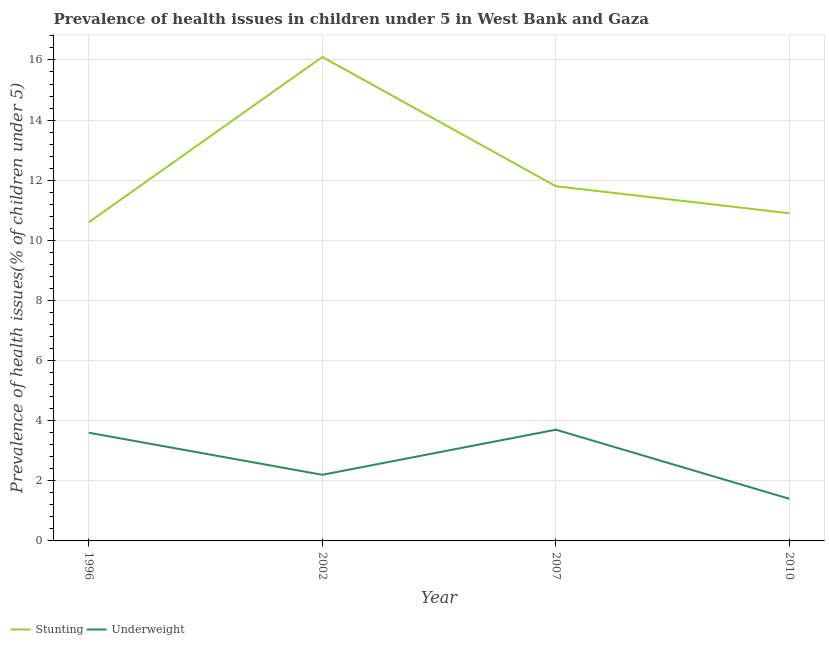Does the line corresponding to percentage of underweight children intersect with the line corresponding to percentage of stunted children?
Your answer should be very brief. No. What is the percentage of stunted children in 2007?
Offer a terse response. 11.8. Across all years, what is the maximum percentage of underweight children?
Ensure brevity in your answer.  3.7. Across all years, what is the minimum percentage of underweight children?
Ensure brevity in your answer.  1.4. In which year was the percentage of underweight children maximum?
Make the answer very short. 2007. What is the total percentage of underweight children in the graph?
Your answer should be very brief. 10.9. What is the difference between the percentage of underweight children in 1996 and that in 2002?
Offer a very short reply. 1.4. What is the difference between the percentage of stunted children in 2007 and the percentage of underweight children in 2002?
Provide a short and direct response. 9.6. What is the average percentage of stunted children per year?
Provide a succinct answer. 12.35. In the year 2007, what is the difference between the percentage of stunted children and percentage of underweight children?
Ensure brevity in your answer.  8.1. In how many years, is the percentage of stunted children greater than 11.2 %?
Give a very brief answer. 2. What is the ratio of the percentage of stunted children in 1996 to that in 2010?
Make the answer very short. 0.97. Is the percentage of underweight children in 2007 less than that in 2010?
Your response must be concise. No. What is the difference between the highest and the second highest percentage of underweight children?
Give a very brief answer. 0.1. What is the difference between the highest and the lowest percentage of underweight children?
Keep it short and to the point. 2.3. In how many years, is the percentage of underweight children greater than the average percentage of underweight children taken over all years?
Keep it short and to the point. 2. Does the percentage of stunted children monotonically increase over the years?
Keep it short and to the point. No. Is the percentage of underweight children strictly less than the percentage of stunted children over the years?
Offer a very short reply. Yes. How many lines are there?
Make the answer very short. 2. What is the difference between two consecutive major ticks on the Y-axis?
Make the answer very short. 2. Does the graph contain grids?
Your response must be concise. Yes. How many legend labels are there?
Your response must be concise. 2. How are the legend labels stacked?
Provide a short and direct response. Horizontal. What is the title of the graph?
Keep it short and to the point. Prevalence of health issues in children under 5 in West Bank and Gaza. What is the label or title of the Y-axis?
Provide a short and direct response. Prevalence of health issues(% of children under 5). What is the Prevalence of health issues(% of children under 5) in Stunting in 1996?
Offer a very short reply. 10.6. What is the Prevalence of health issues(% of children under 5) in Underweight in 1996?
Keep it short and to the point. 3.6. What is the Prevalence of health issues(% of children under 5) of Stunting in 2002?
Make the answer very short. 16.1. What is the Prevalence of health issues(% of children under 5) in Underweight in 2002?
Provide a succinct answer. 2.2. What is the Prevalence of health issues(% of children under 5) of Stunting in 2007?
Offer a terse response. 11.8. What is the Prevalence of health issues(% of children under 5) in Underweight in 2007?
Provide a short and direct response. 3.7. What is the Prevalence of health issues(% of children under 5) of Stunting in 2010?
Your answer should be very brief. 10.9. What is the Prevalence of health issues(% of children under 5) of Underweight in 2010?
Ensure brevity in your answer.  1.4. Across all years, what is the maximum Prevalence of health issues(% of children under 5) of Stunting?
Offer a terse response. 16.1. Across all years, what is the maximum Prevalence of health issues(% of children under 5) of Underweight?
Keep it short and to the point. 3.7. Across all years, what is the minimum Prevalence of health issues(% of children under 5) in Stunting?
Your answer should be compact. 10.6. Across all years, what is the minimum Prevalence of health issues(% of children under 5) in Underweight?
Provide a short and direct response. 1.4. What is the total Prevalence of health issues(% of children under 5) in Stunting in the graph?
Your answer should be compact. 49.4. What is the difference between the Prevalence of health issues(% of children under 5) in Underweight in 1996 and that in 2002?
Your response must be concise. 1.4. What is the difference between the Prevalence of health issues(% of children under 5) in Underweight in 1996 and that in 2007?
Give a very brief answer. -0.1. What is the difference between the Prevalence of health issues(% of children under 5) in Underweight in 1996 and that in 2010?
Provide a succinct answer. 2.2. What is the difference between the Prevalence of health issues(% of children under 5) of Underweight in 2002 and that in 2007?
Your answer should be very brief. -1.5. What is the difference between the Prevalence of health issues(% of children under 5) in Underweight in 2002 and that in 2010?
Provide a short and direct response. 0.8. What is the difference between the Prevalence of health issues(% of children under 5) in Stunting in 2007 and that in 2010?
Provide a short and direct response. 0.9. What is the difference between the Prevalence of health issues(% of children under 5) of Stunting in 1996 and the Prevalence of health issues(% of children under 5) of Underweight in 2007?
Make the answer very short. 6.9. What is the difference between the Prevalence of health issues(% of children under 5) in Stunting in 1996 and the Prevalence of health issues(% of children under 5) in Underweight in 2010?
Ensure brevity in your answer.  9.2. What is the difference between the Prevalence of health issues(% of children under 5) of Stunting in 2002 and the Prevalence of health issues(% of children under 5) of Underweight in 2007?
Make the answer very short. 12.4. What is the average Prevalence of health issues(% of children under 5) of Stunting per year?
Provide a short and direct response. 12.35. What is the average Prevalence of health issues(% of children under 5) in Underweight per year?
Keep it short and to the point. 2.73. In the year 1996, what is the difference between the Prevalence of health issues(% of children under 5) in Stunting and Prevalence of health issues(% of children under 5) in Underweight?
Ensure brevity in your answer.  7. In the year 2002, what is the difference between the Prevalence of health issues(% of children under 5) in Stunting and Prevalence of health issues(% of children under 5) in Underweight?
Your response must be concise. 13.9. In the year 2010, what is the difference between the Prevalence of health issues(% of children under 5) in Stunting and Prevalence of health issues(% of children under 5) in Underweight?
Your answer should be very brief. 9.5. What is the ratio of the Prevalence of health issues(% of children under 5) of Stunting in 1996 to that in 2002?
Keep it short and to the point. 0.66. What is the ratio of the Prevalence of health issues(% of children under 5) in Underweight in 1996 to that in 2002?
Offer a very short reply. 1.64. What is the ratio of the Prevalence of health issues(% of children under 5) of Stunting in 1996 to that in 2007?
Give a very brief answer. 0.9. What is the ratio of the Prevalence of health issues(% of children under 5) of Stunting in 1996 to that in 2010?
Your answer should be very brief. 0.97. What is the ratio of the Prevalence of health issues(% of children under 5) of Underweight in 1996 to that in 2010?
Ensure brevity in your answer.  2.57. What is the ratio of the Prevalence of health issues(% of children under 5) in Stunting in 2002 to that in 2007?
Ensure brevity in your answer.  1.36. What is the ratio of the Prevalence of health issues(% of children under 5) of Underweight in 2002 to that in 2007?
Offer a very short reply. 0.59. What is the ratio of the Prevalence of health issues(% of children under 5) in Stunting in 2002 to that in 2010?
Keep it short and to the point. 1.48. What is the ratio of the Prevalence of health issues(% of children under 5) of Underweight in 2002 to that in 2010?
Keep it short and to the point. 1.57. What is the ratio of the Prevalence of health issues(% of children under 5) of Stunting in 2007 to that in 2010?
Ensure brevity in your answer.  1.08. What is the ratio of the Prevalence of health issues(% of children under 5) of Underweight in 2007 to that in 2010?
Keep it short and to the point. 2.64. What is the difference between the highest and the second highest Prevalence of health issues(% of children under 5) of Stunting?
Provide a short and direct response. 4.3. What is the difference between the highest and the lowest Prevalence of health issues(% of children under 5) of Underweight?
Your answer should be very brief. 2.3. 